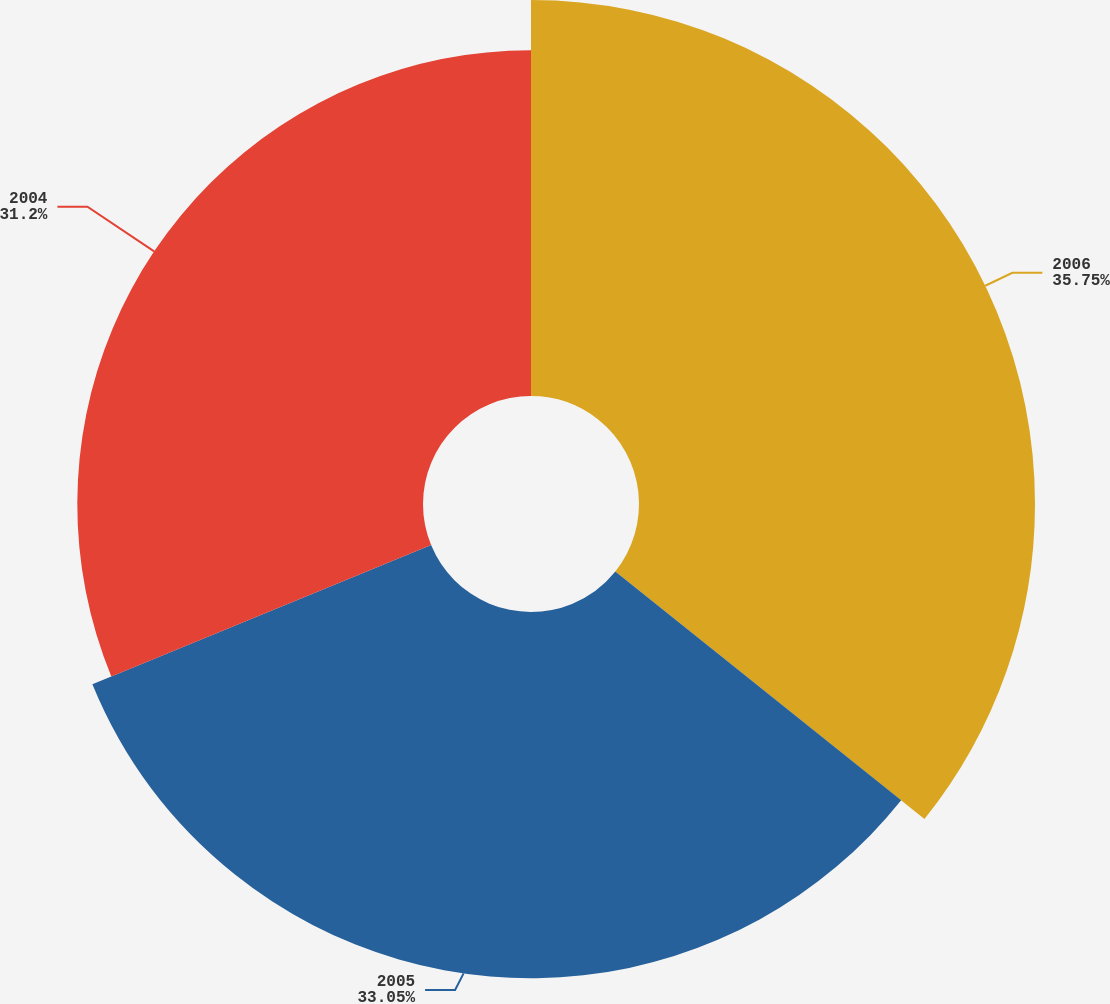Convert chart to OTSL. <chart><loc_0><loc_0><loc_500><loc_500><pie_chart><fcel>2006<fcel>2005<fcel>2004<nl><fcel>35.74%<fcel>33.05%<fcel>31.2%<nl></chart> 